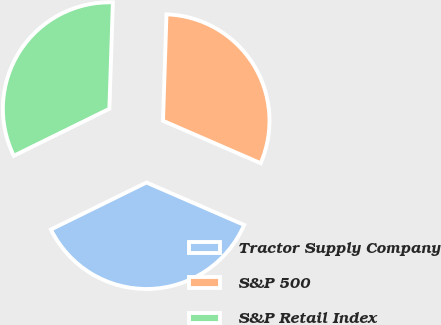Convert chart. <chart><loc_0><loc_0><loc_500><loc_500><pie_chart><fcel>Tractor Supply Company<fcel>S&P 500<fcel>S&P Retail Index<nl><fcel>36.2%<fcel>31.0%<fcel>32.8%<nl></chart> 